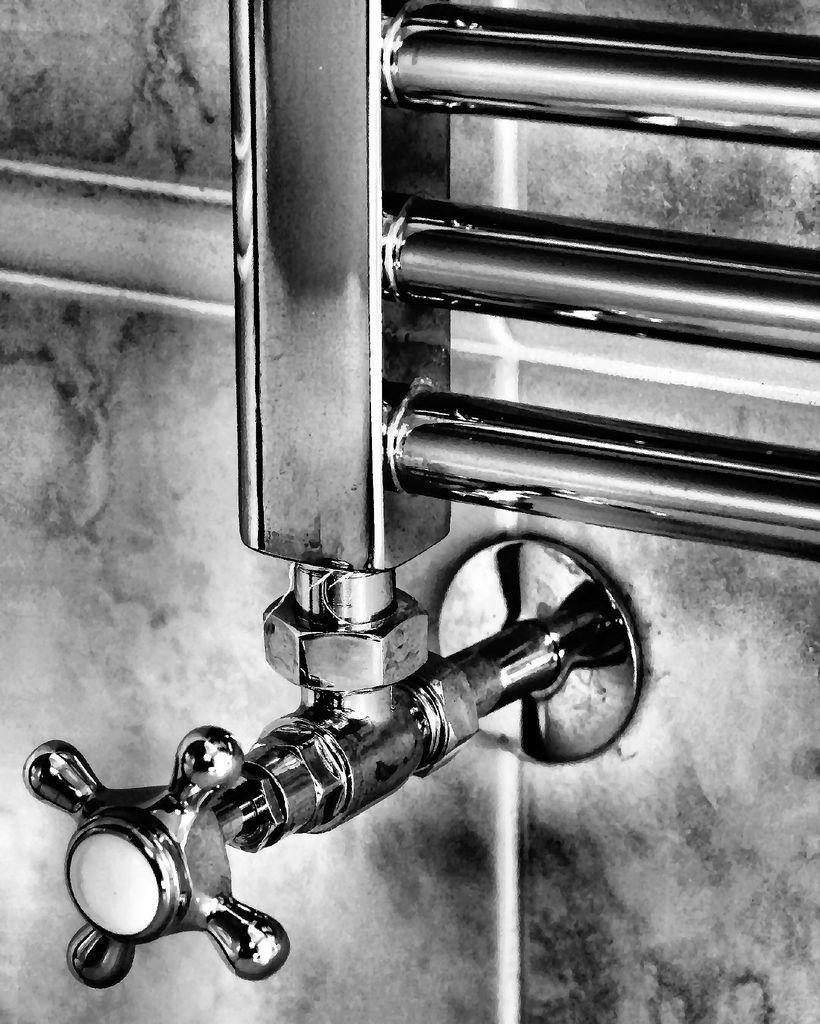In one or two sentences, can you explain what this image depicts? In this image we can see a tap, pipes, also we can see the wall, and the picture is taken in black and white mode. 